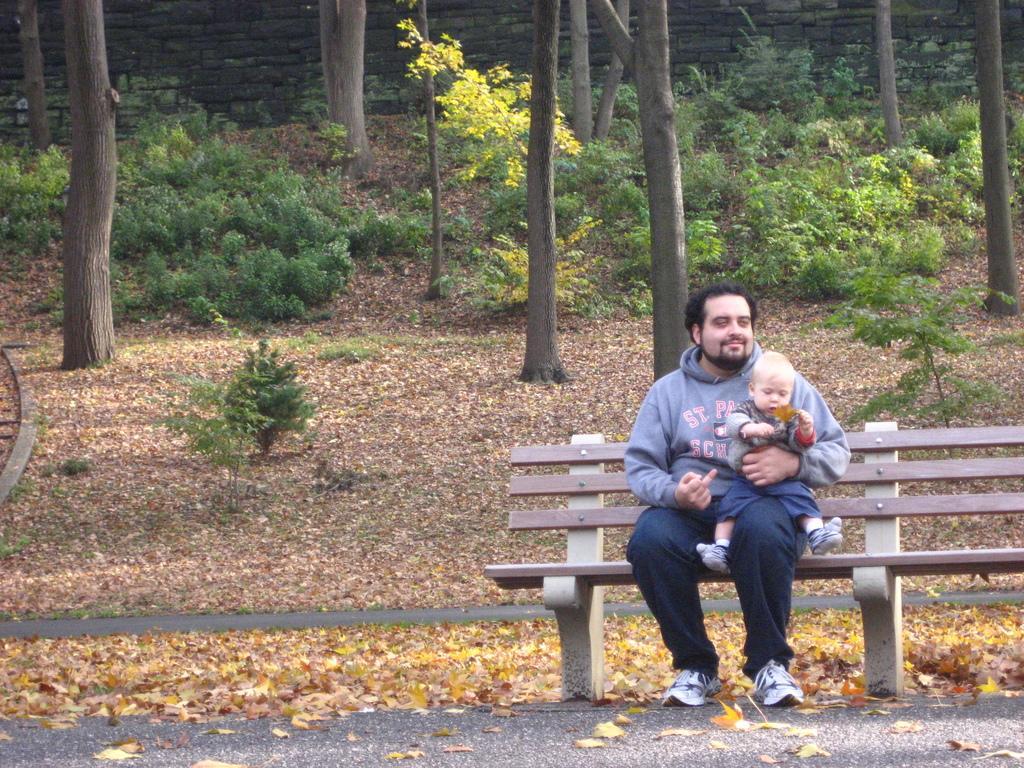How would you summarize this image in a sentence or two? In this image there is person and baby sitting in the bench in the back ground there are plants , trees, grass and leaves. 